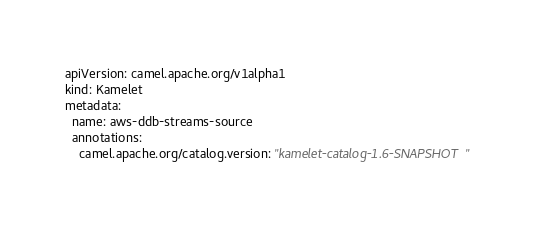<code> <loc_0><loc_0><loc_500><loc_500><_YAML_>apiVersion: camel.apache.org/v1alpha1
kind: Kamelet
metadata:
  name: aws-ddb-streams-source
  annotations:
    camel.apache.org/catalog.version: "kamelet-catalog-1.6-SNAPSHOT"</code> 